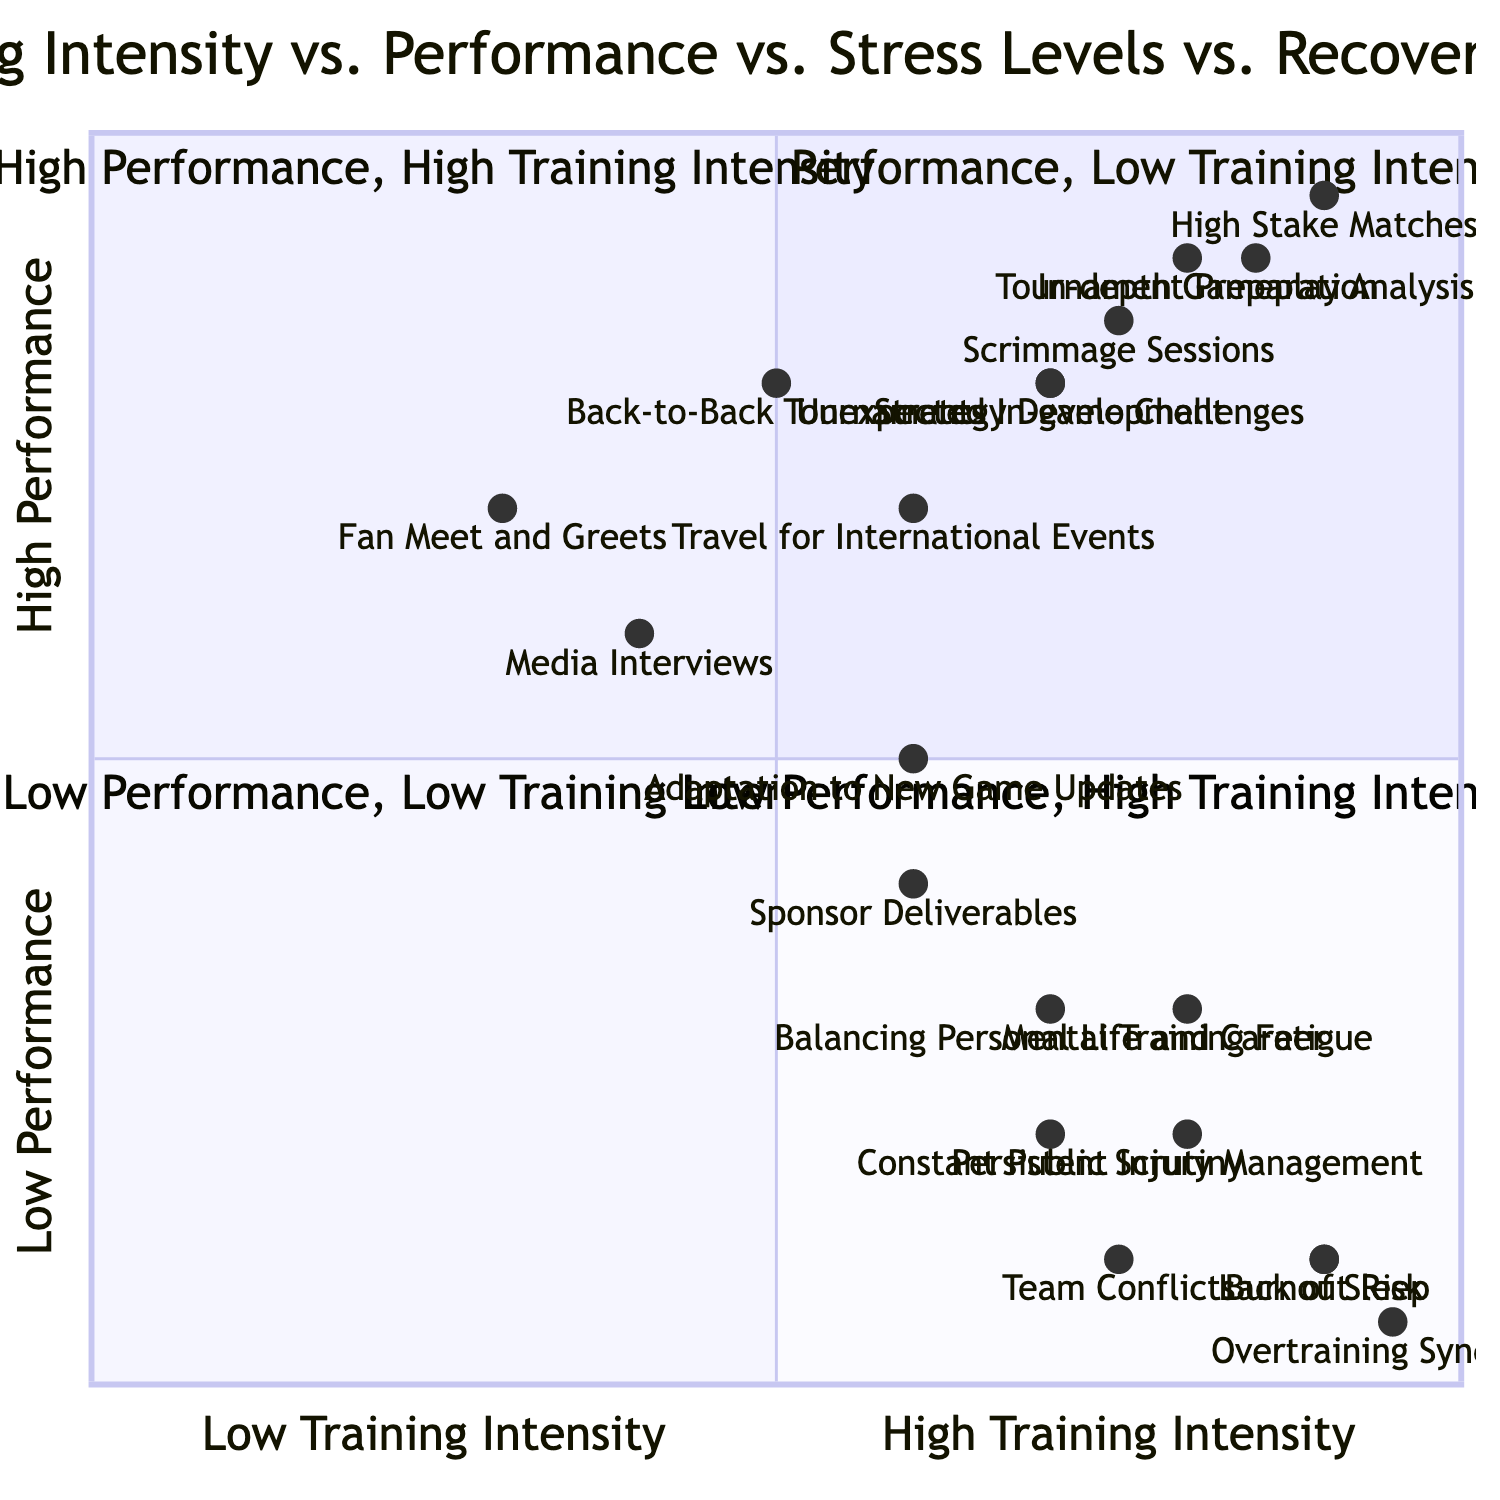What is presented in the quadrant for "High Training Intensity, High Performance"? The quadrant for "High Training Intensity, High Performance" includes elements such as Tournament Preparation, Scrimmage Sessions, Strategy Development, High Stake Matches, and In-depth Gameplay Analysis.
Answer: Tournament Preparation, Scrimmage Sessions, Strategy Development, High Stake Matches, In-depth Gameplay Analysis How many elements are in the "High Stress Levels, Low Recovery Time" quadrant? There are five elements listed in the "High Stress Levels, Low Recovery Time" quadrant, which are Persistent Injury Management, Lack of Sleep, Overtraining Syndrome, Balancing Personal Life and Career, and Adaptation to New Game Updates.
Answer: 5 Which activity is associated with the highest performance but has low recovery time? "Back-to-Back Tournaments" is the activity that is associated with high performance while having low recovery time. It is located in the quadrant labeled "High Performance, Low Recovery Time."
Answer: Back-to-Back Tournaments What is the relationship between "Mental Training Fatigue" and "Burnout Risk"? Both "Mental Training Fatigue" and "Burnout Risk" are placed in the "High Training Intensity, High Stress Levels" quadrant, indicating they are associated with high training intensity and high stress, impacting an athlete's mental health.
Answer: High Training Intensity, High Stress Levels Which element has the highest stress level in the quadrant of "High Stress Levels, Low Recovery Time"? "Overtraining Syndrome" has the highest stress level in the "High Stress Levels, Low Recovery Time" quadrant with a value near 0.05 for performance, while maintaining a high stress level.
Answer: Overtraining Syndrome What is the position of "Fan Meet and Greets" in relation to training intensity and performance? "Fan Meet and Greets" is located in the "High Performance, Low Training Intensity" area, indicating that it has high performance but low training intensity.
Answer: High Performance, Low Training Intensity 